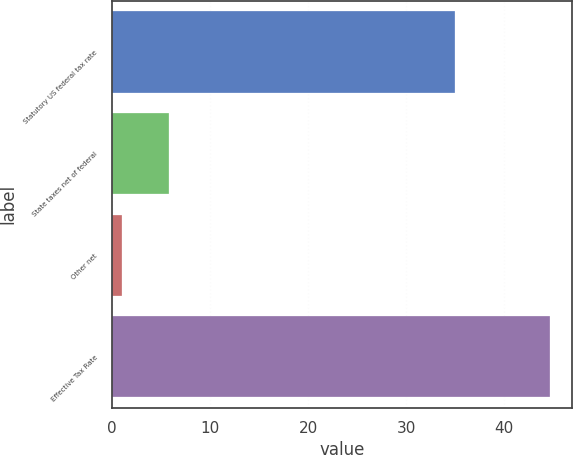Convert chart to OTSL. <chart><loc_0><loc_0><loc_500><loc_500><bar_chart><fcel>Statutory US federal tax rate<fcel>State taxes net of federal<fcel>Other net<fcel>Effective Tax Rate<nl><fcel>35<fcel>5.8<fcel>1<fcel>44.7<nl></chart> 